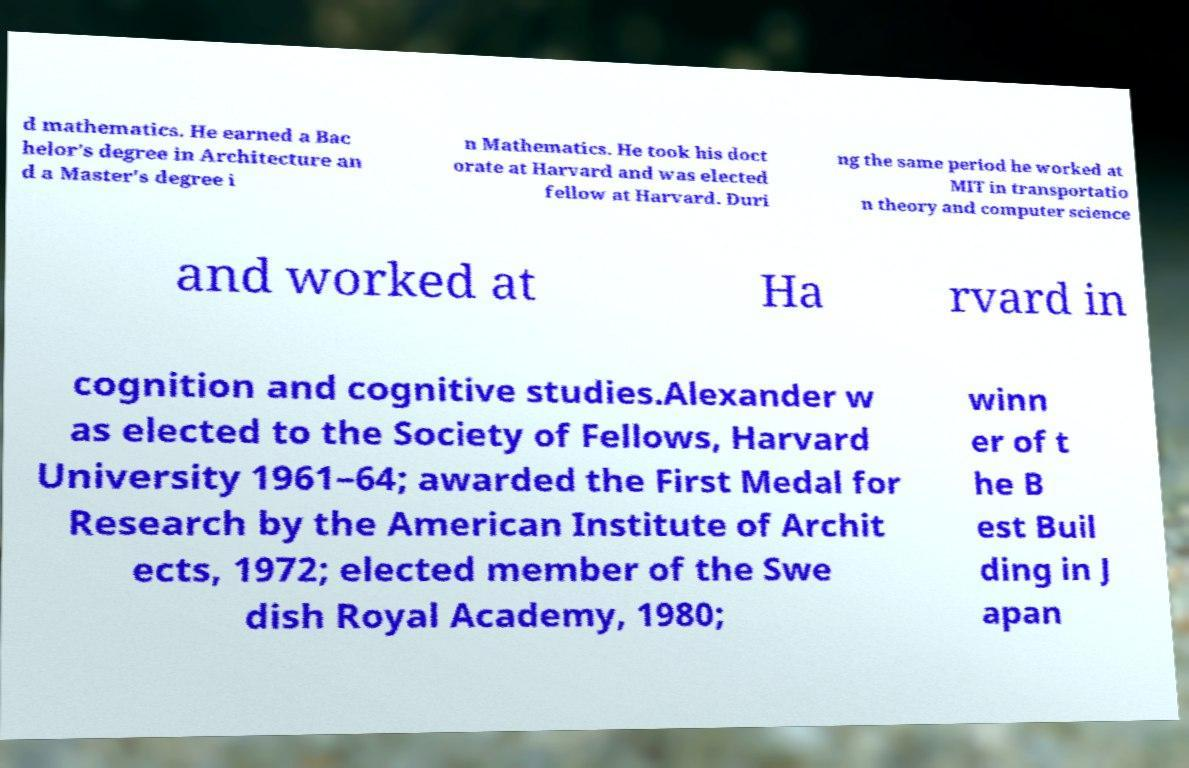Could you extract and type out the text from this image? d mathematics. He earned a Bac helor's degree in Architecture an d a Master's degree i n Mathematics. He took his doct orate at Harvard and was elected fellow at Harvard. Duri ng the same period he worked at MIT in transportatio n theory and computer science and worked at Ha rvard in cognition and cognitive studies.Alexander w as elected to the Society of Fellows, Harvard University 1961–64; awarded the First Medal for Research by the American Institute of Archit ects, 1972; elected member of the Swe dish Royal Academy, 1980; winn er of t he B est Buil ding in J apan 